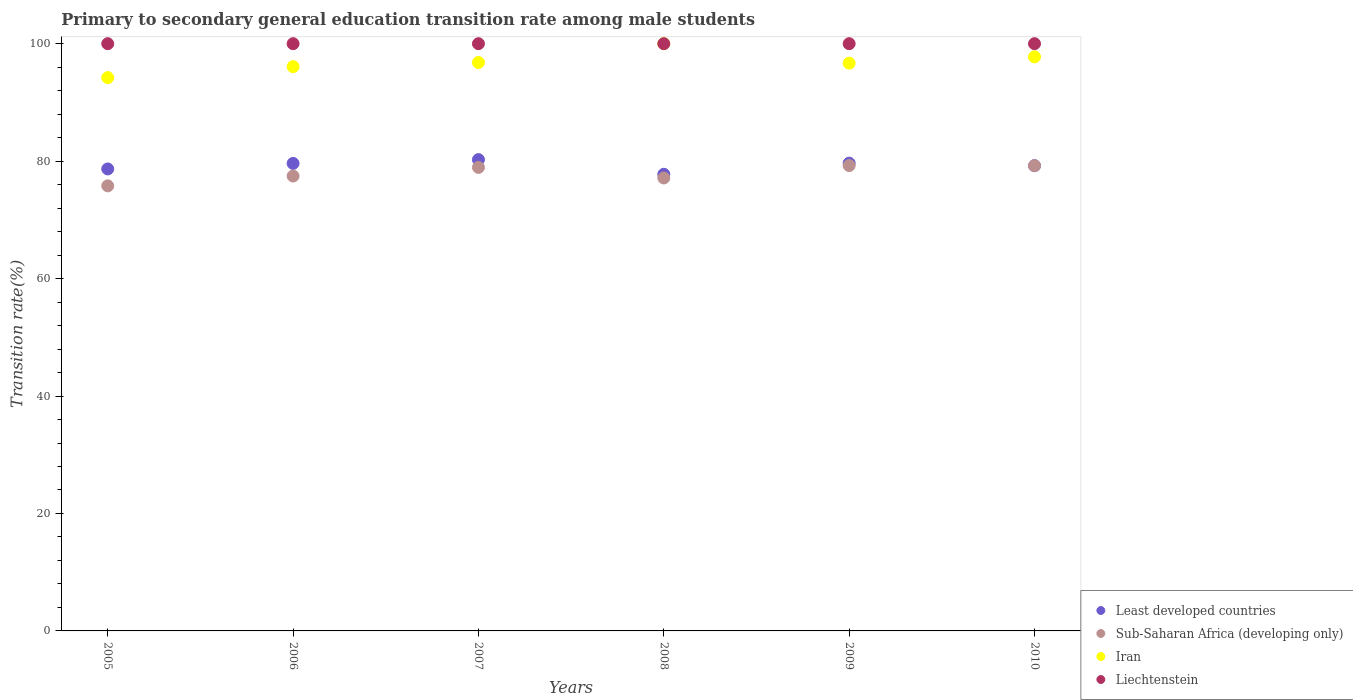How many different coloured dotlines are there?
Provide a short and direct response. 4. What is the transition rate in Sub-Saharan Africa (developing only) in 2007?
Provide a short and direct response. 78.93. Across all years, what is the minimum transition rate in Sub-Saharan Africa (developing only)?
Provide a succinct answer. 75.79. In which year was the transition rate in Iran minimum?
Offer a very short reply. 2005. What is the total transition rate in Iran in the graph?
Offer a terse response. 581.54. What is the difference between the transition rate in Sub-Saharan Africa (developing only) in 2005 and that in 2006?
Keep it short and to the point. -1.67. What is the difference between the transition rate in Sub-Saharan Africa (developing only) in 2006 and the transition rate in Iran in 2007?
Ensure brevity in your answer.  -19.34. What is the average transition rate in Iran per year?
Provide a succinct answer. 96.92. In the year 2006, what is the difference between the transition rate in Sub-Saharan Africa (developing only) and transition rate in Least developed countries?
Ensure brevity in your answer.  -2.15. What is the ratio of the transition rate in Iran in 2005 to that in 2008?
Give a very brief answer. 0.94. What is the difference between the highest and the second highest transition rate in Iran?
Ensure brevity in your answer.  2.24. What is the difference between the highest and the lowest transition rate in Least developed countries?
Ensure brevity in your answer.  2.5. Is it the case that in every year, the sum of the transition rate in Least developed countries and transition rate in Sub-Saharan Africa (developing only)  is greater than the sum of transition rate in Liechtenstein and transition rate in Iran?
Your answer should be compact. No. Is it the case that in every year, the sum of the transition rate in Liechtenstein and transition rate in Iran  is greater than the transition rate in Sub-Saharan Africa (developing only)?
Your answer should be very brief. Yes. Does the transition rate in Iran monotonically increase over the years?
Offer a very short reply. No. Is the transition rate in Liechtenstein strictly greater than the transition rate in Least developed countries over the years?
Provide a short and direct response. Yes. Is the transition rate in Liechtenstein strictly less than the transition rate in Iran over the years?
Provide a short and direct response. No. How many years are there in the graph?
Ensure brevity in your answer.  6. Are the values on the major ticks of Y-axis written in scientific E-notation?
Give a very brief answer. No. Does the graph contain grids?
Provide a short and direct response. No. How many legend labels are there?
Give a very brief answer. 4. How are the legend labels stacked?
Make the answer very short. Vertical. What is the title of the graph?
Keep it short and to the point. Primary to secondary general education transition rate among male students. What is the label or title of the X-axis?
Give a very brief answer. Years. What is the label or title of the Y-axis?
Ensure brevity in your answer.  Transition rate(%). What is the Transition rate(%) of Least developed countries in 2005?
Give a very brief answer. 78.67. What is the Transition rate(%) in Sub-Saharan Africa (developing only) in 2005?
Offer a very short reply. 75.79. What is the Transition rate(%) in Iran in 2005?
Make the answer very short. 94.22. What is the Transition rate(%) of Least developed countries in 2006?
Your response must be concise. 79.61. What is the Transition rate(%) in Sub-Saharan Africa (developing only) in 2006?
Make the answer very short. 77.46. What is the Transition rate(%) in Iran in 2006?
Provide a succinct answer. 96.09. What is the Transition rate(%) in Least developed countries in 2007?
Your response must be concise. 80.26. What is the Transition rate(%) in Sub-Saharan Africa (developing only) in 2007?
Offer a very short reply. 78.93. What is the Transition rate(%) of Iran in 2007?
Offer a terse response. 96.8. What is the Transition rate(%) of Liechtenstein in 2007?
Give a very brief answer. 100. What is the Transition rate(%) of Least developed countries in 2008?
Your answer should be compact. 77.76. What is the Transition rate(%) in Sub-Saharan Africa (developing only) in 2008?
Offer a terse response. 77.13. What is the Transition rate(%) in Liechtenstein in 2008?
Your answer should be compact. 100. What is the Transition rate(%) in Least developed countries in 2009?
Make the answer very short. 79.66. What is the Transition rate(%) in Sub-Saharan Africa (developing only) in 2009?
Provide a short and direct response. 79.25. What is the Transition rate(%) in Iran in 2009?
Provide a short and direct response. 96.68. What is the Transition rate(%) of Least developed countries in 2010?
Ensure brevity in your answer.  79.23. What is the Transition rate(%) of Sub-Saharan Africa (developing only) in 2010?
Your answer should be compact. 79.22. What is the Transition rate(%) of Iran in 2010?
Your answer should be very brief. 97.76. What is the Transition rate(%) of Liechtenstein in 2010?
Provide a succinct answer. 100. Across all years, what is the maximum Transition rate(%) of Least developed countries?
Your answer should be very brief. 80.26. Across all years, what is the maximum Transition rate(%) in Sub-Saharan Africa (developing only)?
Offer a terse response. 79.25. Across all years, what is the minimum Transition rate(%) in Least developed countries?
Your answer should be compact. 77.76. Across all years, what is the minimum Transition rate(%) in Sub-Saharan Africa (developing only)?
Make the answer very short. 75.79. Across all years, what is the minimum Transition rate(%) in Iran?
Ensure brevity in your answer.  94.22. What is the total Transition rate(%) of Least developed countries in the graph?
Your answer should be compact. 475.19. What is the total Transition rate(%) in Sub-Saharan Africa (developing only) in the graph?
Keep it short and to the point. 467.77. What is the total Transition rate(%) of Iran in the graph?
Provide a short and direct response. 581.54. What is the total Transition rate(%) of Liechtenstein in the graph?
Your answer should be compact. 600. What is the difference between the Transition rate(%) of Least developed countries in 2005 and that in 2006?
Offer a very short reply. -0.94. What is the difference between the Transition rate(%) in Sub-Saharan Africa (developing only) in 2005 and that in 2006?
Offer a very short reply. -1.67. What is the difference between the Transition rate(%) in Iran in 2005 and that in 2006?
Give a very brief answer. -1.87. What is the difference between the Transition rate(%) of Least developed countries in 2005 and that in 2007?
Offer a very short reply. -1.59. What is the difference between the Transition rate(%) of Sub-Saharan Africa (developing only) in 2005 and that in 2007?
Offer a terse response. -3.14. What is the difference between the Transition rate(%) of Iran in 2005 and that in 2007?
Your answer should be very brief. -2.57. What is the difference between the Transition rate(%) in Least developed countries in 2005 and that in 2008?
Your answer should be compact. 0.91. What is the difference between the Transition rate(%) of Sub-Saharan Africa (developing only) in 2005 and that in 2008?
Offer a terse response. -1.34. What is the difference between the Transition rate(%) in Iran in 2005 and that in 2008?
Give a very brief answer. -5.78. What is the difference between the Transition rate(%) of Least developed countries in 2005 and that in 2009?
Offer a very short reply. -0.99. What is the difference between the Transition rate(%) of Sub-Saharan Africa (developing only) in 2005 and that in 2009?
Keep it short and to the point. -3.46. What is the difference between the Transition rate(%) of Iran in 2005 and that in 2009?
Provide a succinct answer. -2.46. What is the difference between the Transition rate(%) of Liechtenstein in 2005 and that in 2009?
Your response must be concise. 0. What is the difference between the Transition rate(%) in Least developed countries in 2005 and that in 2010?
Ensure brevity in your answer.  -0.57. What is the difference between the Transition rate(%) in Sub-Saharan Africa (developing only) in 2005 and that in 2010?
Make the answer very short. -3.43. What is the difference between the Transition rate(%) of Iran in 2005 and that in 2010?
Provide a succinct answer. -3.54. What is the difference between the Transition rate(%) in Least developed countries in 2006 and that in 2007?
Your answer should be very brief. -0.65. What is the difference between the Transition rate(%) of Sub-Saharan Africa (developing only) in 2006 and that in 2007?
Provide a succinct answer. -1.47. What is the difference between the Transition rate(%) in Iran in 2006 and that in 2007?
Offer a terse response. -0.71. What is the difference between the Transition rate(%) of Least developed countries in 2006 and that in 2008?
Give a very brief answer. 1.85. What is the difference between the Transition rate(%) in Sub-Saharan Africa (developing only) in 2006 and that in 2008?
Provide a succinct answer. 0.33. What is the difference between the Transition rate(%) in Iran in 2006 and that in 2008?
Ensure brevity in your answer.  -3.91. What is the difference between the Transition rate(%) in Liechtenstein in 2006 and that in 2008?
Offer a very short reply. 0. What is the difference between the Transition rate(%) in Least developed countries in 2006 and that in 2009?
Offer a very short reply. -0.04. What is the difference between the Transition rate(%) of Sub-Saharan Africa (developing only) in 2006 and that in 2009?
Give a very brief answer. -1.79. What is the difference between the Transition rate(%) of Iran in 2006 and that in 2009?
Provide a short and direct response. -0.6. What is the difference between the Transition rate(%) of Least developed countries in 2006 and that in 2010?
Your response must be concise. 0.38. What is the difference between the Transition rate(%) in Sub-Saharan Africa (developing only) in 2006 and that in 2010?
Provide a short and direct response. -1.76. What is the difference between the Transition rate(%) of Iran in 2006 and that in 2010?
Provide a succinct answer. -1.67. What is the difference between the Transition rate(%) in Liechtenstein in 2006 and that in 2010?
Provide a short and direct response. 0. What is the difference between the Transition rate(%) in Least developed countries in 2007 and that in 2008?
Keep it short and to the point. 2.5. What is the difference between the Transition rate(%) of Sub-Saharan Africa (developing only) in 2007 and that in 2008?
Your answer should be very brief. 1.8. What is the difference between the Transition rate(%) in Iran in 2007 and that in 2008?
Ensure brevity in your answer.  -3.2. What is the difference between the Transition rate(%) of Liechtenstein in 2007 and that in 2008?
Your response must be concise. 0. What is the difference between the Transition rate(%) of Least developed countries in 2007 and that in 2009?
Keep it short and to the point. 0.61. What is the difference between the Transition rate(%) in Sub-Saharan Africa (developing only) in 2007 and that in 2009?
Provide a succinct answer. -0.32. What is the difference between the Transition rate(%) of Iran in 2007 and that in 2009?
Your response must be concise. 0.11. What is the difference between the Transition rate(%) of Liechtenstein in 2007 and that in 2009?
Make the answer very short. 0. What is the difference between the Transition rate(%) in Least developed countries in 2007 and that in 2010?
Keep it short and to the point. 1.03. What is the difference between the Transition rate(%) of Sub-Saharan Africa (developing only) in 2007 and that in 2010?
Provide a short and direct response. -0.29. What is the difference between the Transition rate(%) of Iran in 2007 and that in 2010?
Make the answer very short. -0.96. What is the difference between the Transition rate(%) of Least developed countries in 2008 and that in 2009?
Ensure brevity in your answer.  -1.9. What is the difference between the Transition rate(%) in Sub-Saharan Africa (developing only) in 2008 and that in 2009?
Your answer should be very brief. -2.12. What is the difference between the Transition rate(%) in Iran in 2008 and that in 2009?
Provide a short and direct response. 3.32. What is the difference between the Transition rate(%) of Liechtenstein in 2008 and that in 2009?
Offer a very short reply. 0. What is the difference between the Transition rate(%) in Least developed countries in 2008 and that in 2010?
Provide a short and direct response. -1.47. What is the difference between the Transition rate(%) of Sub-Saharan Africa (developing only) in 2008 and that in 2010?
Offer a very short reply. -2.09. What is the difference between the Transition rate(%) of Iran in 2008 and that in 2010?
Offer a terse response. 2.24. What is the difference between the Transition rate(%) of Least developed countries in 2009 and that in 2010?
Offer a terse response. 0.42. What is the difference between the Transition rate(%) in Sub-Saharan Africa (developing only) in 2009 and that in 2010?
Keep it short and to the point. 0.03. What is the difference between the Transition rate(%) of Iran in 2009 and that in 2010?
Your answer should be compact. -1.07. What is the difference between the Transition rate(%) of Liechtenstein in 2009 and that in 2010?
Give a very brief answer. 0. What is the difference between the Transition rate(%) in Least developed countries in 2005 and the Transition rate(%) in Sub-Saharan Africa (developing only) in 2006?
Give a very brief answer. 1.21. What is the difference between the Transition rate(%) of Least developed countries in 2005 and the Transition rate(%) of Iran in 2006?
Offer a terse response. -17.42. What is the difference between the Transition rate(%) in Least developed countries in 2005 and the Transition rate(%) in Liechtenstein in 2006?
Make the answer very short. -21.33. What is the difference between the Transition rate(%) in Sub-Saharan Africa (developing only) in 2005 and the Transition rate(%) in Iran in 2006?
Your answer should be very brief. -20.3. What is the difference between the Transition rate(%) in Sub-Saharan Africa (developing only) in 2005 and the Transition rate(%) in Liechtenstein in 2006?
Provide a short and direct response. -24.21. What is the difference between the Transition rate(%) in Iran in 2005 and the Transition rate(%) in Liechtenstein in 2006?
Make the answer very short. -5.78. What is the difference between the Transition rate(%) of Least developed countries in 2005 and the Transition rate(%) of Sub-Saharan Africa (developing only) in 2007?
Provide a short and direct response. -0.26. What is the difference between the Transition rate(%) of Least developed countries in 2005 and the Transition rate(%) of Iran in 2007?
Ensure brevity in your answer.  -18.13. What is the difference between the Transition rate(%) of Least developed countries in 2005 and the Transition rate(%) of Liechtenstein in 2007?
Offer a very short reply. -21.33. What is the difference between the Transition rate(%) in Sub-Saharan Africa (developing only) in 2005 and the Transition rate(%) in Iran in 2007?
Give a very brief answer. -21. What is the difference between the Transition rate(%) in Sub-Saharan Africa (developing only) in 2005 and the Transition rate(%) in Liechtenstein in 2007?
Offer a very short reply. -24.21. What is the difference between the Transition rate(%) in Iran in 2005 and the Transition rate(%) in Liechtenstein in 2007?
Ensure brevity in your answer.  -5.78. What is the difference between the Transition rate(%) of Least developed countries in 2005 and the Transition rate(%) of Sub-Saharan Africa (developing only) in 2008?
Your answer should be very brief. 1.54. What is the difference between the Transition rate(%) in Least developed countries in 2005 and the Transition rate(%) in Iran in 2008?
Give a very brief answer. -21.33. What is the difference between the Transition rate(%) in Least developed countries in 2005 and the Transition rate(%) in Liechtenstein in 2008?
Provide a short and direct response. -21.33. What is the difference between the Transition rate(%) in Sub-Saharan Africa (developing only) in 2005 and the Transition rate(%) in Iran in 2008?
Ensure brevity in your answer.  -24.21. What is the difference between the Transition rate(%) of Sub-Saharan Africa (developing only) in 2005 and the Transition rate(%) of Liechtenstein in 2008?
Your response must be concise. -24.21. What is the difference between the Transition rate(%) in Iran in 2005 and the Transition rate(%) in Liechtenstein in 2008?
Make the answer very short. -5.78. What is the difference between the Transition rate(%) of Least developed countries in 2005 and the Transition rate(%) of Sub-Saharan Africa (developing only) in 2009?
Ensure brevity in your answer.  -0.58. What is the difference between the Transition rate(%) in Least developed countries in 2005 and the Transition rate(%) in Iran in 2009?
Offer a terse response. -18.01. What is the difference between the Transition rate(%) of Least developed countries in 2005 and the Transition rate(%) of Liechtenstein in 2009?
Offer a terse response. -21.33. What is the difference between the Transition rate(%) of Sub-Saharan Africa (developing only) in 2005 and the Transition rate(%) of Iran in 2009?
Ensure brevity in your answer.  -20.89. What is the difference between the Transition rate(%) in Sub-Saharan Africa (developing only) in 2005 and the Transition rate(%) in Liechtenstein in 2009?
Your response must be concise. -24.21. What is the difference between the Transition rate(%) in Iran in 2005 and the Transition rate(%) in Liechtenstein in 2009?
Make the answer very short. -5.78. What is the difference between the Transition rate(%) of Least developed countries in 2005 and the Transition rate(%) of Sub-Saharan Africa (developing only) in 2010?
Provide a short and direct response. -0.55. What is the difference between the Transition rate(%) in Least developed countries in 2005 and the Transition rate(%) in Iran in 2010?
Keep it short and to the point. -19.09. What is the difference between the Transition rate(%) of Least developed countries in 2005 and the Transition rate(%) of Liechtenstein in 2010?
Make the answer very short. -21.33. What is the difference between the Transition rate(%) in Sub-Saharan Africa (developing only) in 2005 and the Transition rate(%) in Iran in 2010?
Your response must be concise. -21.97. What is the difference between the Transition rate(%) of Sub-Saharan Africa (developing only) in 2005 and the Transition rate(%) of Liechtenstein in 2010?
Make the answer very short. -24.21. What is the difference between the Transition rate(%) in Iran in 2005 and the Transition rate(%) in Liechtenstein in 2010?
Ensure brevity in your answer.  -5.78. What is the difference between the Transition rate(%) in Least developed countries in 2006 and the Transition rate(%) in Sub-Saharan Africa (developing only) in 2007?
Your response must be concise. 0.68. What is the difference between the Transition rate(%) in Least developed countries in 2006 and the Transition rate(%) in Iran in 2007?
Your answer should be very brief. -17.18. What is the difference between the Transition rate(%) in Least developed countries in 2006 and the Transition rate(%) in Liechtenstein in 2007?
Give a very brief answer. -20.39. What is the difference between the Transition rate(%) of Sub-Saharan Africa (developing only) in 2006 and the Transition rate(%) of Iran in 2007?
Provide a succinct answer. -19.34. What is the difference between the Transition rate(%) in Sub-Saharan Africa (developing only) in 2006 and the Transition rate(%) in Liechtenstein in 2007?
Your response must be concise. -22.54. What is the difference between the Transition rate(%) of Iran in 2006 and the Transition rate(%) of Liechtenstein in 2007?
Provide a short and direct response. -3.91. What is the difference between the Transition rate(%) in Least developed countries in 2006 and the Transition rate(%) in Sub-Saharan Africa (developing only) in 2008?
Your answer should be very brief. 2.48. What is the difference between the Transition rate(%) of Least developed countries in 2006 and the Transition rate(%) of Iran in 2008?
Make the answer very short. -20.39. What is the difference between the Transition rate(%) of Least developed countries in 2006 and the Transition rate(%) of Liechtenstein in 2008?
Your answer should be compact. -20.39. What is the difference between the Transition rate(%) of Sub-Saharan Africa (developing only) in 2006 and the Transition rate(%) of Iran in 2008?
Make the answer very short. -22.54. What is the difference between the Transition rate(%) of Sub-Saharan Africa (developing only) in 2006 and the Transition rate(%) of Liechtenstein in 2008?
Make the answer very short. -22.54. What is the difference between the Transition rate(%) of Iran in 2006 and the Transition rate(%) of Liechtenstein in 2008?
Your answer should be compact. -3.91. What is the difference between the Transition rate(%) in Least developed countries in 2006 and the Transition rate(%) in Sub-Saharan Africa (developing only) in 2009?
Your response must be concise. 0.37. What is the difference between the Transition rate(%) in Least developed countries in 2006 and the Transition rate(%) in Iran in 2009?
Offer a terse response. -17.07. What is the difference between the Transition rate(%) in Least developed countries in 2006 and the Transition rate(%) in Liechtenstein in 2009?
Provide a succinct answer. -20.39. What is the difference between the Transition rate(%) in Sub-Saharan Africa (developing only) in 2006 and the Transition rate(%) in Iran in 2009?
Provide a succinct answer. -19.22. What is the difference between the Transition rate(%) in Sub-Saharan Africa (developing only) in 2006 and the Transition rate(%) in Liechtenstein in 2009?
Offer a very short reply. -22.54. What is the difference between the Transition rate(%) in Iran in 2006 and the Transition rate(%) in Liechtenstein in 2009?
Keep it short and to the point. -3.91. What is the difference between the Transition rate(%) in Least developed countries in 2006 and the Transition rate(%) in Sub-Saharan Africa (developing only) in 2010?
Your answer should be compact. 0.4. What is the difference between the Transition rate(%) of Least developed countries in 2006 and the Transition rate(%) of Iran in 2010?
Offer a very short reply. -18.14. What is the difference between the Transition rate(%) of Least developed countries in 2006 and the Transition rate(%) of Liechtenstein in 2010?
Give a very brief answer. -20.39. What is the difference between the Transition rate(%) in Sub-Saharan Africa (developing only) in 2006 and the Transition rate(%) in Iran in 2010?
Your answer should be compact. -20.3. What is the difference between the Transition rate(%) of Sub-Saharan Africa (developing only) in 2006 and the Transition rate(%) of Liechtenstein in 2010?
Your answer should be compact. -22.54. What is the difference between the Transition rate(%) in Iran in 2006 and the Transition rate(%) in Liechtenstein in 2010?
Offer a terse response. -3.91. What is the difference between the Transition rate(%) in Least developed countries in 2007 and the Transition rate(%) in Sub-Saharan Africa (developing only) in 2008?
Give a very brief answer. 3.13. What is the difference between the Transition rate(%) in Least developed countries in 2007 and the Transition rate(%) in Iran in 2008?
Provide a succinct answer. -19.74. What is the difference between the Transition rate(%) of Least developed countries in 2007 and the Transition rate(%) of Liechtenstein in 2008?
Your answer should be very brief. -19.74. What is the difference between the Transition rate(%) in Sub-Saharan Africa (developing only) in 2007 and the Transition rate(%) in Iran in 2008?
Keep it short and to the point. -21.07. What is the difference between the Transition rate(%) in Sub-Saharan Africa (developing only) in 2007 and the Transition rate(%) in Liechtenstein in 2008?
Your answer should be very brief. -21.07. What is the difference between the Transition rate(%) of Iran in 2007 and the Transition rate(%) of Liechtenstein in 2008?
Give a very brief answer. -3.2. What is the difference between the Transition rate(%) in Least developed countries in 2007 and the Transition rate(%) in Sub-Saharan Africa (developing only) in 2009?
Give a very brief answer. 1.02. What is the difference between the Transition rate(%) of Least developed countries in 2007 and the Transition rate(%) of Iran in 2009?
Provide a succinct answer. -16.42. What is the difference between the Transition rate(%) in Least developed countries in 2007 and the Transition rate(%) in Liechtenstein in 2009?
Keep it short and to the point. -19.74. What is the difference between the Transition rate(%) in Sub-Saharan Africa (developing only) in 2007 and the Transition rate(%) in Iran in 2009?
Offer a terse response. -17.75. What is the difference between the Transition rate(%) of Sub-Saharan Africa (developing only) in 2007 and the Transition rate(%) of Liechtenstein in 2009?
Keep it short and to the point. -21.07. What is the difference between the Transition rate(%) of Iran in 2007 and the Transition rate(%) of Liechtenstein in 2009?
Offer a terse response. -3.2. What is the difference between the Transition rate(%) of Least developed countries in 2007 and the Transition rate(%) of Sub-Saharan Africa (developing only) in 2010?
Give a very brief answer. 1.04. What is the difference between the Transition rate(%) of Least developed countries in 2007 and the Transition rate(%) of Iran in 2010?
Keep it short and to the point. -17.5. What is the difference between the Transition rate(%) in Least developed countries in 2007 and the Transition rate(%) in Liechtenstein in 2010?
Give a very brief answer. -19.74. What is the difference between the Transition rate(%) of Sub-Saharan Africa (developing only) in 2007 and the Transition rate(%) of Iran in 2010?
Make the answer very short. -18.83. What is the difference between the Transition rate(%) of Sub-Saharan Africa (developing only) in 2007 and the Transition rate(%) of Liechtenstein in 2010?
Keep it short and to the point. -21.07. What is the difference between the Transition rate(%) in Iran in 2007 and the Transition rate(%) in Liechtenstein in 2010?
Make the answer very short. -3.2. What is the difference between the Transition rate(%) in Least developed countries in 2008 and the Transition rate(%) in Sub-Saharan Africa (developing only) in 2009?
Offer a terse response. -1.49. What is the difference between the Transition rate(%) of Least developed countries in 2008 and the Transition rate(%) of Iran in 2009?
Provide a short and direct response. -18.92. What is the difference between the Transition rate(%) in Least developed countries in 2008 and the Transition rate(%) in Liechtenstein in 2009?
Your answer should be compact. -22.24. What is the difference between the Transition rate(%) of Sub-Saharan Africa (developing only) in 2008 and the Transition rate(%) of Iran in 2009?
Provide a succinct answer. -19.55. What is the difference between the Transition rate(%) in Sub-Saharan Africa (developing only) in 2008 and the Transition rate(%) in Liechtenstein in 2009?
Your answer should be very brief. -22.87. What is the difference between the Transition rate(%) of Iran in 2008 and the Transition rate(%) of Liechtenstein in 2009?
Provide a short and direct response. 0. What is the difference between the Transition rate(%) in Least developed countries in 2008 and the Transition rate(%) in Sub-Saharan Africa (developing only) in 2010?
Offer a very short reply. -1.46. What is the difference between the Transition rate(%) in Least developed countries in 2008 and the Transition rate(%) in Iran in 2010?
Your response must be concise. -20. What is the difference between the Transition rate(%) in Least developed countries in 2008 and the Transition rate(%) in Liechtenstein in 2010?
Keep it short and to the point. -22.24. What is the difference between the Transition rate(%) in Sub-Saharan Africa (developing only) in 2008 and the Transition rate(%) in Iran in 2010?
Offer a very short reply. -20.63. What is the difference between the Transition rate(%) in Sub-Saharan Africa (developing only) in 2008 and the Transition rate(%) in Liechtenstein in 2010?
Your answer should be very brief. -22.87. What is the difference between the Transition rate(%) of Least developed countries in 2009 and the Transition rate(%) of Sub-Saharan Africa (developing only) in 2010?
Your answer should be very brief. 0.44. What is the difference between the Transition rate(%) in Least developed countries in 2009 and the Transition rate(%) in Iran in 2010?
Give a very brief answer. -18.1. What is the difference between the Transition rate(%) in Least developed countries in 2009 and the Transition rate(%) in Liechtenstein in 2010?
Make the answer very short. -20.34. What is the difference between the Transition rate(%) of Sub-Saharan Africa (developing only) in 2009 and the Transition rate(%) of Iran in 2010?
Ensure brevity in your answer.  -18.51. What is the difference between the Transition rate(%) of Sub-Saharan Africa (developing only) in 2009 and the Transition rate(%) of Liechtenstein in 2010?
Give a very brief answer. -20.75. What is the difference between the Transition rate(%) in Iran in 2009 and the Transition rate(%) in Liechtenstein in 2010?
Your answer should be compact. -3.32. What is the average Transition rate(%) in Least developed countries per year?
Provide a succinct answer. 79.2. What is the average Transition rate(%) of Sub-Saharan Africa (developing only) per year?
Offer a very short reply. 77.96. What is the average Transition rate(%) of Iran per year?
Provide a succinct answer. 96.92. What is the average Transition rate(%) of Liechtenstein per year?
Provide a succinct answer. 100. In the year 2005, what is the difference between the Transition rate(%) of Least developed countries and Transition rate(%) of Sub-Saharan Africa (developing only)?
Make the answer very short. 2.88. In the year 2005, what is the difference between the Transition rate(%) in Least developed countries and Transition rate(%) in Iran?
Offer a terse response. -15.55. In the year 2005, what is the difference between the Transition rate(%) in Least developed countries and Transition rate(%) in Liechtenstein?
Provide a short and direct response. -21.33. In the year 2005, what is the difference between the Transition rate(%) in Sub-Saharan Africa (developing only) and Transition rate(%) in Iran?
Give a very brief answer. -18.43. In the year 2005, what is the difference between the Transition rate(%) of Sub-Saharan Africa (developing only) and Transition rate(%) of Liechtenstein?
Provide a short and direct response. -24.21. In the year 2005, what is the difference between the Transition rate(%) in Iran and Transition rate(%) in Liechtenstein?
Provide a short and direct response. -5.78. In the year 2006, what is the difference between the Transition rate(%) in Least developed countries and Transition rate(%) in Sub-Saharan Africa (developing only)?
Keep it short and to the point. 2.15. In the year 2006, what is the difference between the Transition rate(%) of Least developed countries and Transition rate(%) of Iran?
Make the answer very short. -16.47. In the year 2006, what is the difference between the Transition rate(%) in Least developed countries and Transition rate(%) in Liechtenstein?
Your answer should be very brief. -20.39. In the year 2006, what is the difference between the Transition rate(%) of Sub-Saharan Africa (developing only) and Transition rate(%) of Iran?
Keep it short and to the point. -18.63. In the year 2006, what is the difference between the Transition rate(%) of Sub-Saharan Africa (developing only) and Transition rate(%) of Liechtenstein?
Offer a terse response. -22.54. In the year 2006, what is the difference between the Transition rate(%) of Iran and Transition rate(%) of Liechtenstein?
Give a very brief answer. -3.91. In the year 2007, what is the difference between the Transition rate(%) of Least developed countries and Transition rate(%) of Sub-Saharan Africa (developing only)?
Provide a short and direct response. 1.33. In the year 2007, what is the difference between the Transition rate(%) in Least developed countries and Transition rate(%) in Iran?
Ensure brevity in your answer.  -16.53. In the year 2007, what is the difference between the Transition rate(%) of Least developed countries and Transition rate(%) of Liechtenstein?
Give a very brief answer. -19.74. In the year 2007, what is the difference between the Transition rate(%) of Sub-Saharan Africa (developing only) and Transition rate(%) of Iran?
Your answer should be very brief. -17.87. In the year 2007, what is the difference between the Transition rate(%) in Sub-Saharan Africa (developing only) and Transition rate(%) in Liechtenstein?
Your response must be concise. -21.07. In the year 2007, what is the difference between the Transition rate(%) of Iran and Transition rate(%) of Liechtenstein?
Make the answer very short. -3.2. In the year 2008, what is the difference between the Transition rate(%) of Least developed countries and Transition rate(%) of Sub-Saharan Africa (developing only)?
Make the answer very short. 0.63. In the year 2008, what is the difference between the Transition rate(%) of Least developed countries and Transition rate(%) of Iran?
Your answer should be compact. -22.24. In the year 2008, what is the difference between the Transition rate(%) in Least developed countries and Transition rate(%) in Liechtenstein?
Offer a terse response. -22.24. In the year 2008, what is the difference between the Transition rate(%) in Sub-Saharan Africa (developing only) and Transition rate(%) in Iran?
Your answer should be very brief. -22.87. In the year 2008, what is the difference between the Transition rate(%) of Sub-Saharan Africa (developing only) and Transition rate(%) of Liechtenstein?
Your response must be concise. -22.87. In the year 2009, what is the difference between the Transition rate(%) in Least developed countries and Transition rate(%) in Sub-Saharan Africa (developing only)?
Make the answer very short. 0.41. In the year 2009, what is the difference between the Transition rate(%) in Least developed countries and Transition rate(%) in Iran?
Provide a succinct answer. -17.03. In the year 2009, what is the difference between the Transition rate(%) of Least developed countries and Transition rate(%) of Liechtenstein?
Provide a succinct answer. -20.34. In the year 2009, what is the difference between the Transition rate(%) in Sub-Saharan Africa (developing only) and Transition rate(%) in Iran?
Offer a terse response. -17.44. In the year 2009, what is the difference between the Transition rate(%) of Sub-Saharan Africa (developing only) and Transition rate(%) of Liechtenstein?
Your response must be concise. -20.75. In the year 2009, what is the difference between the Transition rate(%) in Iran and Transition rate(%) in Liechtenstein?
Give a very brief answer. -3.32. In the year 2010, what is the difference between the Transition rate(%) of Least developed countries and Transition rate(%) of Sub-Saharan Africa (developing only)?
Offer a very short reply. 0.02. In the year 2010, what is the difference between the Transition rate(%) in Least developed countries and Transition rate(%) in Iran?
Offer a very short reply. -18.52. In the year 2010, what is the difference between the Transition rate(%) of Least developed countries and Transition rate(%) of Liechtenstein?
Provide a short and direct response. -20.77. In the year 2010, what is the difference between the Transition rate(%) of Sub-Saharan Africa (developing only) and Transition rate(%) of Iran?
Offer a very short reply. -18.54. In the year 2010, what is the difference between the Transition rate(%) in Sub-Saharan Africa (developing only) and Transition rate(%) in Liechtenstein?
Your answer should be compact. -20.78. In the year 2010, what is the difference between the Transition rate(%) in Iran and Transition rate(%) in Liechtenstein?
Provide a succinct answer. -2.24. What is the ratio of the Transition rate(%) in Least developed countries in 2005 to that in 2006?
Keep it short and to the point. 0.99. What is the ratio of the Transition rate(%) in Sub-Saharan Africa (developing only) in 2005 to that in 2006?
Provide a short and direct response. 0.98. What is the ratio of the Transition rate(%) of Iran in 2005 to that in 2006?
Offer a terse response. 0.98. What is the ratio of the Transition rate(%) in Liechtenstein in 2005 to that in 2006?
Give a very brief answer. 1. What is the ratio of the Transition rate(%) of Least developed countries in 2005 to that in 2007?
Offer a very short reply. 0.98. What is the ratio of the Transition rate(%) of Sub-Saharan Africa (developing only) in 2005 to that in 2007?
Keep it short and to the point. 0.96. What is the ratio of the Transition rate(%) of Iran in 2005 to that in 2007?
Your response must be concise. 0.97. What is the ratio of the Transition rate(%) in Least developed countries in 2005 to that in 2008?
Ensure brevity in your answer.  1.01. What is the ratio of the Transition rate(%) of Sub-Saharan Africa (developing only) in 2005 to that in 2008?
Your answer should be very brief. 0.98. What is the ratio of the Transition rate(%) of Iran in 2005 to that in 2008?
Make the answer very short. 0.94. What is the ratio of the Transition rate(%) of Liechtenstein in 2005 to that in 2008?
Keep it short and to the point. 1. What is the ratio of the Transition rate(%) of Least developed countries in 2005 to that in 2009?
Keep it short and to the point. 0.99. What is the ratio of the Transition rate(%) in Sub-Saharan Africa (developing only) in 2005 to that in 2009?
Give a very brief answer. 0.96. What is the ratio of the Transition rate(%) of Iran in 2005 to that in 2009?
Ensure brevity in your answer.  0.97. What is the ratio of the Transition rate(%) of Liechtenstein in 2005 to that in 2009?
Your response must be concise. 1. What is the ratio of the Transition rate(%) in Least developed countries in 2005 to that in 2010?
Provide a short and direct response. 0.99. What is the ratio of the Transition rate(%) in Sub-Saharan Africa (developing only) in 2005 to that in 2010?
Offer a terse response. 0.96. What is the ratio of the Transition rate(%) of Iran in 2005 to that in 2010?
Your answer should be compact. 0.96. What is the ratio of the Transition rate(%) in Liechtenstein in 2005 to that in 2010?
Your answer should be compact. 1. What is the ratio of the Transition rate(%) in Sub-Saharan Africa (developing only) in 2006 to that in 2007?
Your answer should be compact. 0.98. What is the ratio of the Transition rate(%) in Iran in 2006 to that in 2007?
Make the answer very short. 0.99. What is the ratio of the Transition rate(%) in Liechtenstein in 2006 to that in 2007?
Provide a succinct answer. 1. What is the ratio of the Transition rate(%) in Least developed countries in 2006 to that in 2008?
Give a very brief answer. 1.02. What is the ratio of the Transition rate(%) in Iran in 2006 to that in 2008?
Offer a terse response. 0.96. What is the ratio of the Transition rate(%) of Least developed countries in 2006 to that in 2009?
Provide a short and direct response. 1. What is the ratio of the Transition rate(%) in Sub-Saharan Africa (developing only) in 2006 to that in 2009?
Your response must be concise. 0.98. What is the ratio of the Transition rate(%) in Iran in 2006 to that in 2009?
Your answer should be compact. 0.99. What is the ratio of the Transition rate(%) of Liechtenstein in 2006 to that in 2009?
Your response must be concise. 1. What is the ratio of the Transition rate(%) of Least developed countries in 2006 to that in 2010?
Keep it short and to the point. 1. What is the ratio of the Transition rate(%) of Sub-Saharan Africa (developing only) in 2006 to that in 2010?
Provide a succinct answer. 0.98. What is the ratio of the Transition rate(%) in Iran in 2006 to that in 2010?
Offer a very short reply. 0.98. What is the ratio of the Transition rate(%) in Least developed countries in 2007 to that in 2008?
Give a very brief answer. 1.03. What is the ratio of the Transition rate(%) in Sub-Saharan Africa (developing only) in 2007 to that in 2008?
Your answer should be very brief. 1.02. What is the ratio of the Transition rate(%) of Iran in 2007 to that in 2008?
Provide a succinct answer. 0.97. What is the ratio of the Transition rate(%) in Least developed countries in 2007 to that in 2009?
Provide a short and direct response. 1.01. What is the ratio of the Transition rate(%) in Sub-Saharan Africa (developing only) in 2007 to that in 2009?
Offer a very short reply. 1. What is the ratio of the Transition rate(%) of Iran in 2007 to that in 2010?
Provide a short and direct response. 0.99. What is the ratio of the Transition rate(%) of Least developed countries in 2008 to that in 2009?
Your answer should be very brief. 0.98. What is the ratio of the Transition rate(%) in Sub-Saharan Africa (developing only) in 2008 to that in 2009?
Make the answer very short. 0.97. What is the ratio of the Transition rate(%) in Iran in 2008 to that in 2009?
Provide a succinct answer. 1.03. What is the ratio of the Transition rate(%) of Least developed countries in 2008 to that in 2010?
Provide a short and direct response. 0.98. What is the ratio of the Transition rate(%) of Sub-Saharan Africa (developing only) in 2008 to that in 2010?
Ensure brevity in your answer.  0.97. What is the ratio of the Transition rate(%) in Iran in 2008 to that in 2010?
Provide a short and direct response. 1.02. What is the ratio of the Transition rate(%) in Least developed countries in 2009 to that in 2010?
Give a very brief answer. 1.01. What is the ratio of the Transition rate(%) in Iran in 2009 to that in 2010?
Your answer should be compact. 0.99. What is the ratio of the Transition rate(%) in Liechtenstein in 2009 to that in 2010?
Your response must be concise. 1. What is the difference between the highest and the second highest Transition rate(%) in Least developed countries?
Your answer should be compact. 0.61. What is the difference between the highest and the second highest Transition rate(%) of Sub-Saharan Africa (developing only)?
Your response must be concise. 0.03. What is the difference between the highest and the second highest Transition rate(%) in Iran?
Make the answer very short. 2.24. What is the difference between the highest and the lowest Transition rate(%) in Least developed countries?
Give a very brief answer. 2.5. What is the difference between the highest and the lowest Transition rate(%) of Sub-Saharan Africa (developing only)?
Offer a very short reply. 3.46. What is the difference between the highest and the lowest Transition rate(%) of Iran?
Ensure brevity in your answer.  5.78. What is the difference between the highest and the lowest Transition rate(%) in Liechtenstein?
Your answer should be compact. 0. 